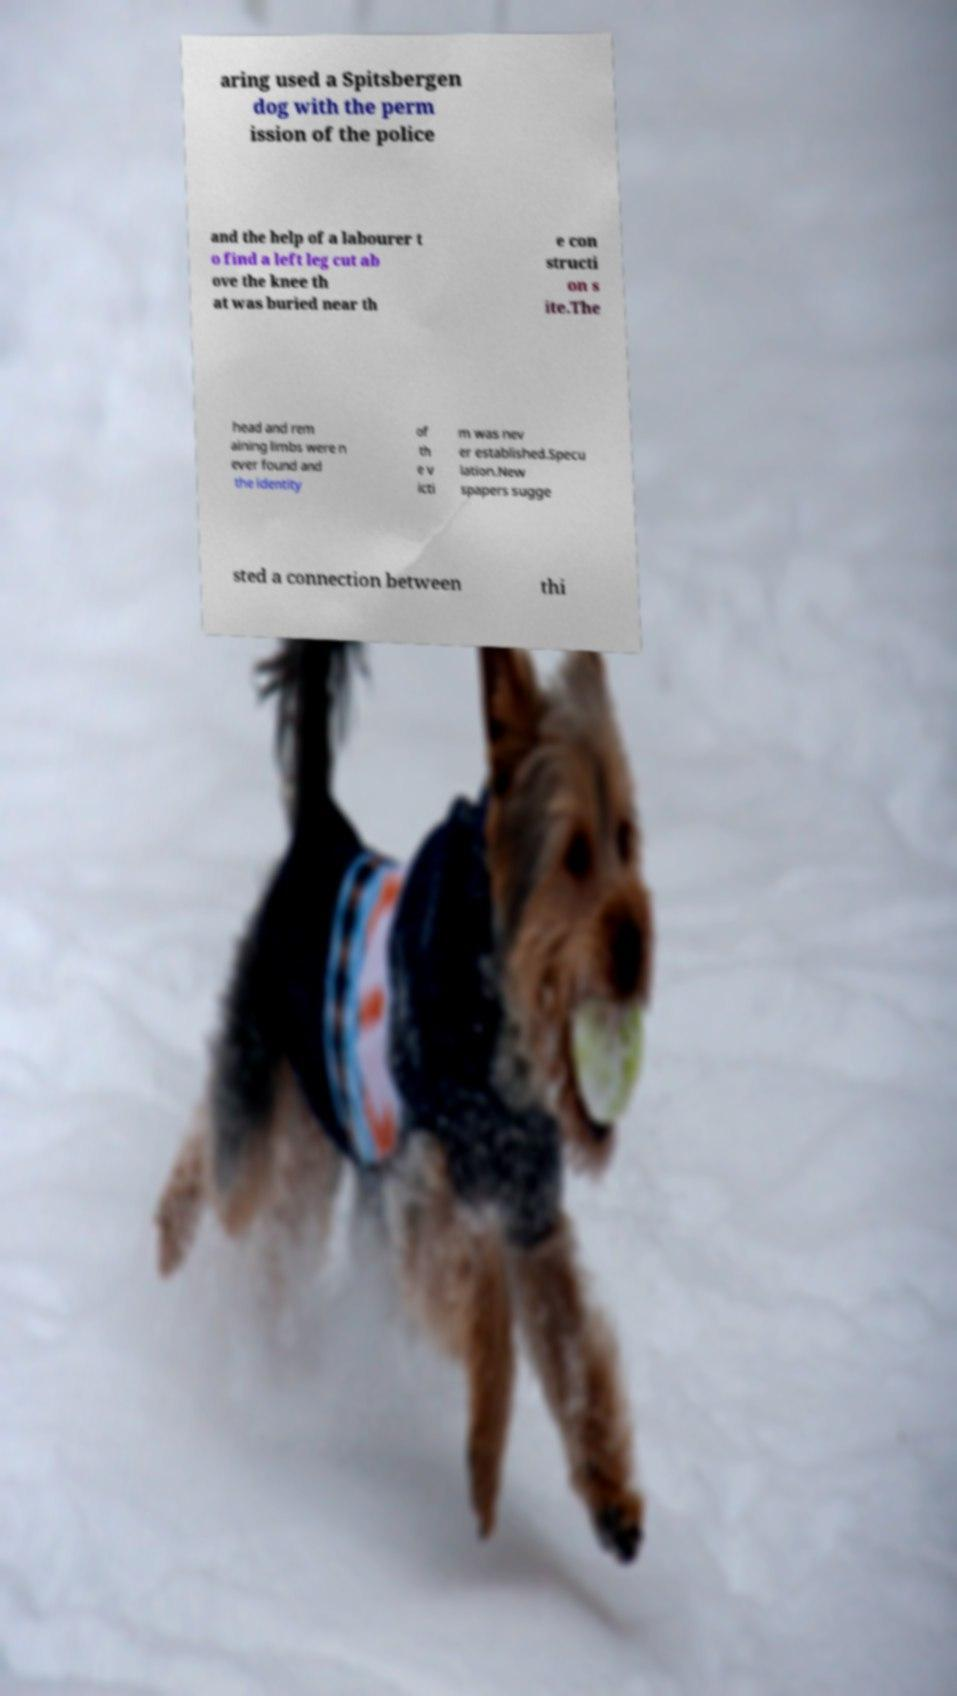Could you extract and type out the text from this image? aring used a Spitsbergen dog with the perm ission of the police and the help of a labourer t o find a left leg cut ab ove the knee th at was buried near th e con structi on s ite.The head and rem aining limbs were n ever found and the identity of th e v icti m was nev er established.Specu lation.New spapers sugge sted a connection between thi 